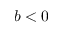Convert formula to latex. <formula><loc_0><loc_0><loc_500><loc_500>b < 0</formula> 